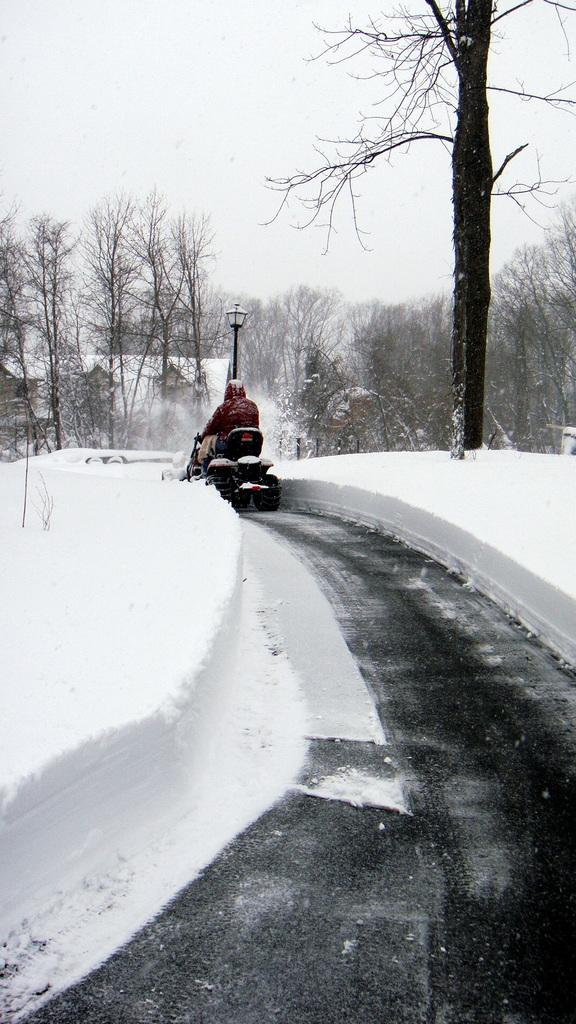What is the person in the image doing? There is a person riding a vehicle on the road in the image. What is the condition of the road in the image? The road has snow on the side in the image. What can be seen in the background of the image? There are trees covered with snow in the background of the image. What type of advertisement can be seen on the side of the road in the image? There is no advertisement present on the side of the road in the image. How many deer are visible in the image? There are no deer visible in the image. 